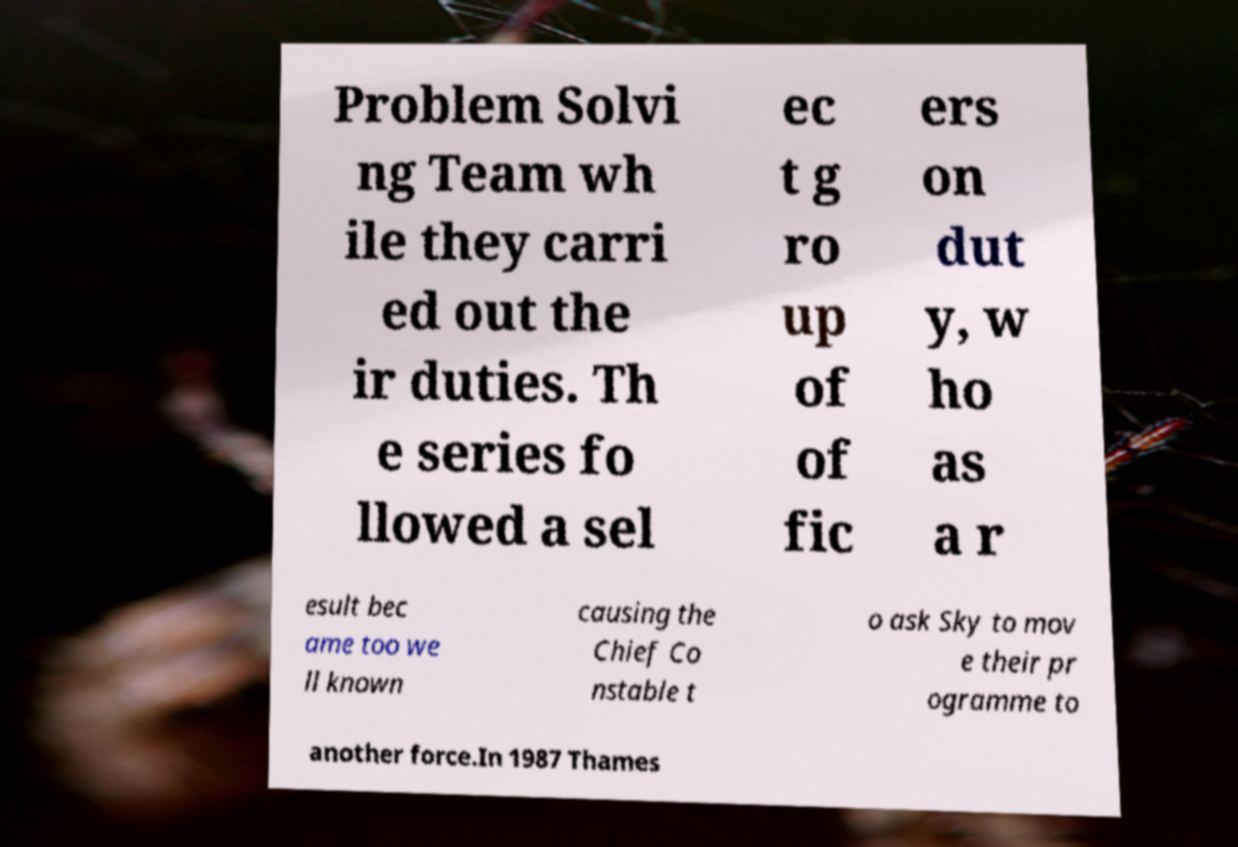For documentation purposes, I need the text within this image transcribed. Could you provide that? Problem Solvi ng Team wh ile they carri ed out the ir duties. Th e series fo llowed a sel ec t g ro up of of fic ers on dut y, w ho as a r esult bec ame too we ll known causing the Chief Co nstable t o ask Sky to mov e their pr ogramme to another force.In 1987 Thames 